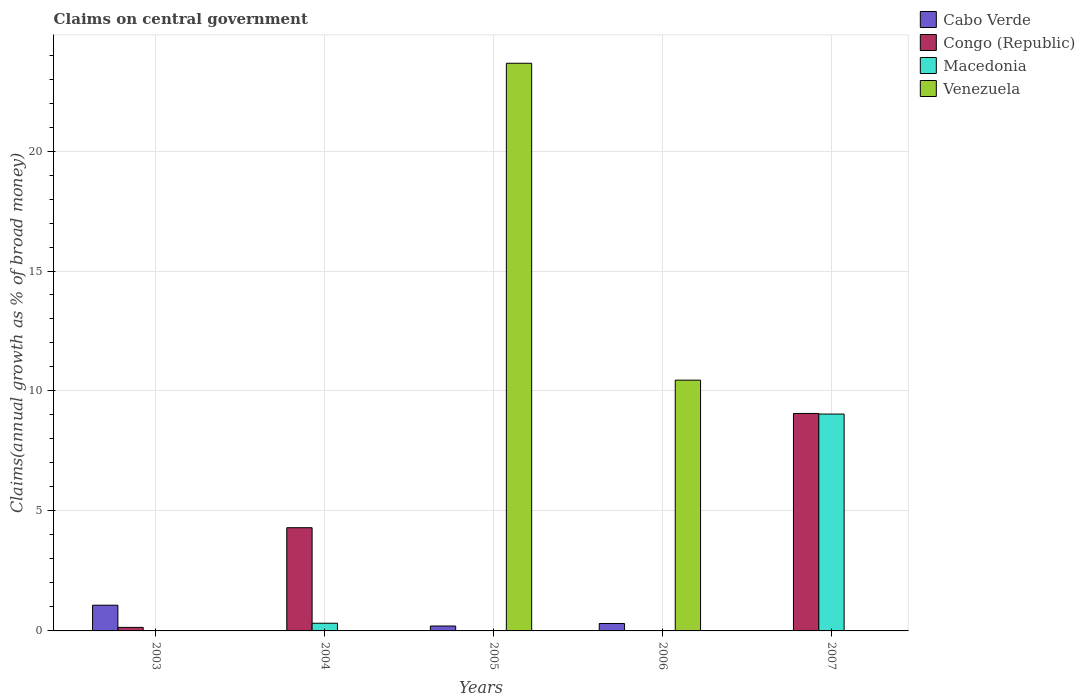How many different coloured bars are there?
Keep it short and to the point. 4. How many groups of bars are there?
Make the answer very short. 5. Are the number of bars on each tick of the X-axis equal?
Your answer should be compact. Yes. How many bars are there on the 5th tick from the left?
Provide a short and direct response. 2. How many bars are there on the 2nd tick from the right?
Give a very brief answer. 2. What is the label of the 5th group of bars from the left?
Offer a terse response. 2007. What is the percentage of broad money claimed on centeral government in Congo (Republic) in 2003?
Offer a very short reply. 0.15. Across all years, what is the maximum percentage of broad money claimed on centeral government in Venezuela?
Keep it short and to the point. 23.66. In which year was the percentage of broad money claimed on centeral government in Congo (Republic) maximum?
Your answer should be very brief. 2007. What is the total percentage of broad money claimed on centeral government in Venezuela in the graph?
Give a very brief answer. 34.11. What is the difference between the percentage of broad money claimed on centeral government in Congo (Republic) in 2004 and that in 2007?
Your answer should be compact. -4.76. What is the difference between the percentage of broad money claimed on centeral government in Venezuela in 2007 and the percentage of broad money claimed on centeral government in Cabo Verde in 2004?
Your answer should be very brief. 0. What is the average percentage of broad money claimed on centeral government in Venezuela per year?
Ensure brevity in your answer.  6.82. In the year 2004, what is the difference between the percentage of broad money claimed on centeral government in Congo (Republic) and percentage of broad money claimed on centeral government in Macedonia?
Give a very brief answer. 3.98. What is the ratio of the percentage of broad money claimed on centeral government in Congo (Republic) in 2004 to that in 2007?
Keep it short and to the point. 0.47. What is the difference between the highest and the second highest percentage of broad money claimed on centeral government in Cabo Verde?
Make the answer very short. 0.76. What is the difference between the highest and the lowest percentage of broad money claimed on centeral government in Congo (Republic)?
Keep it short and to the point. 9.06. In how many years, is the percentage of broad money claimed on centeral government in Venezuela greater than the average percentage of broad money claimed on centeral government in Venezuela taken over all years?
Make the answer very short. 2. Is it the case that in every year, the sum of the percentage of broad money claimed on centeral government in Cabo Verde and percentage of broad money claimed on centeral government in Macedonia is greater than the sum of percentage of broad money claimed on centeral government in Congo (Republic) and percentage of broad money claimed on centeral government in Venezuela?
Give a very brief answer. No. How many bars are there?
Give a very brief answer. 10. Are all the bars in the graph horizontal?
Your response must be concise. No. How many years are there in the graph?
Make the answer very short. 5. What is the difference between two consecutive major ticks on the Y-axis?
Ensure brevity in your answer.  5. Are the values on the major ticks of Y-axis written in scientific E-notation?
Keep it short and to the point. No. Does the graph contain grids?
Keep it short and to the point. Yes. Where does the legend appear in the graph?
Your answer should be compact. Top right. How are the legend labels stacked?
Your answer should be compact. Vertical. What is the title of the graph?
Your response must be concise. Claims on central government. Does "Lesotho" appear as one of the legend labels in the graph?
Provide a short and direct response. No. What is the label or title of the X-axis?
Provide a short and direct response. Years. What is the label or title of the Y-axis?
Give a very brief answer. Claims(annual growth as % of broad money). What is the Claims(annual growth as % of broad money) in Cabo Verde in 2003?
Offer a very short reply. 1.07. What is the Claims(annual growth as % of broad money) of Congo (Republic) in 2003?
Ensure brevity in your answer.  0.15. What is the Claims(annual growth as % of broad money) in Venezuela in 2003?
Make the answer very short. 0. What is the Claims(annual growth as % of broad money) of Cabo Verde in 2004?
Give a very brief answer. 0. What is the Claims(annual growth as % of broad money) in Congo (Republic) in 2004?
Provide a succinct answer. 4.3. What is the Claims(annual growth as % of broad money) in Macedonia in 2004?
Provide a succinct answer. 0.32. What is the Claims(annual growth as % of broad money) of Venezuela in 2004?
Offer a terse response. 0. What is the Claims(annual growth as % of broad money) in Cabo Verde in 2005?
Offer a very short reply. 0.21. What is the Claims(annual growth as % of broad money) of Congo (Republic) in 2005?
Keep it short and to the point. 0. What is the Claims(annual growth as % of broad money) of Macedonia in 2005?
Give a very brief answer. 0. What is the Claims(annual growth as % of broad money) in Venezuela in 2005?
Provide a succinct answer. 23.66. What is the Claims(annual growth as % of broad money) in Cabo Verde in 2006?
Ensure brevity in your answer.  0.31. What is the Claims(annual growth as % of broad money) of Congo (Republic) in 2006?
Keep it short and to the point. 0. What is the Claims(annual growth as % of broad money) in Venezuela in 2006?
Provide a succinct answer. 10.45. What is the Claims(annual growth as % of broad money) in Congo (Republic) in 2007?
Your answer should be compact. 9.06. What is the Claims(annual growth as % of broad money) in Macedonia in 2007?
Ensure brevity in your answer.  9.04. What is the Claims(annual growth as % of broad money) in Venezuela in 2007?
Ensure brevity in your answer.  0. Across all years, what is the maximum Claims(annual growth as % of broad money) of Cabo Verde?
Ensure brevity in your answer.  1.07. Across all years, what is the maximum Claims(annual growth as % of broad money) in Congo (Republic)?
Offer a very short reply. 9.06. Across all years, what is the maximum Claims(annual growth as % of broad money) of Macedonia?
Your answer should be very brief. 9.04. Across all years, what is the maximum Claims(annual growth as % of broad money) of Venezuela?
Provide a short and direct response. 23.66. Across all years, what is the minimum Claims(annual growth as % of broad money) of Cabo Verde?
Your answer should be compact. 0. Across all years, what is the minimum Claims(annual growth as % of broad money) of Congo (Republic)?
Make the answer very short. 0. Across all years, what is the minimum Claims(annual growth as % of broad money) of Macedonia?
Make the answer very short. 0. Across all years, what is the minimum Claims(annual growth as % of broad money) of Venezuela?
Provide a short and direct response. 0. What is the total Claims(annual growth as % of broad money) of Cabo Verde in the graph?
Your response must be concise. 1.59. What is the total Claims(annual growth as % of broad money) in Congo (Republic) in the graph?
Ensure brevity in your answer.  13.51. What is the total Claims(annual growth as % of broad money) in Macedonia in the graph?
Your response must be concise. 9.36. What is the total Claims(annual growth as % of broad money) in Venezuela in the graph?
Ensure brevity in your answer.  34.11. What is the difference between the Claims(annual growth as % of broad money) in Congo (Republic) in 2003 and that in 2004?
Your answer should be very brief. -4.15. What is the difference between the Claims(annual growth as % of broad money) in Cabo Verde in 2003 and that in 2005?
Your response must be concise. 0.87. What is the difference between the Claims(annual growth as % of broad money) of Cabo Verde in 2003 and that in 2006?
Ensure brevity in your answer.  0.76. What is the difference between the Claims(annual growth as % of broad money) of Congo (Republic) in 2003 and that in 2007?
Offer a very short reply. -8.92. What is the difference between the Claims(annual growth as % of broad money) of Congo (Republic) in 2004 and that in 2007?
Provide a short and direct response. -4.76. What is the difference between the Claims(annual growth as % of broad money) in Macedonia in 2004 and that in 2007?
Make the answer very short. -8.72. What is the difference between the Claims(annual growth as % of broad money) in Cabo Verde in 2005 and that in 2006?
Give a very brief answer. -0.1. What is the difference between the Claims(annual growth as % of broad money) in Venezuela in 2005 and that in 2006?
Make the answer very short. 13.21. What is the difference between the Claims(annual growth as % of broad money) in Cabo Verde in 2003 and the Claims(annual growth as % of broad money) in Congo (Republic) in 2004?
Make the answer very short. -3.23. What is the difference between the Claims(annual growth as % of broad money) in Cabo Verde in 2003 and the Claims(annual growth as % of broad money) in Macedonia in 2004?
Your answer should be compact. 0.75. What is the difference between the Claims(annual growth as % of broad money) of Congo (Republic) in 2003 and the Claims(annual growth as % of broad money) of Macedonia in 2004?
Offer a very short reply. -0.17. What is the difference between the Claims(annual growth as % of broad money) of Cabo Verde in 2003 and the Claims(annual growth as % of broad money) of Venezuela in 2005?
Your answer should be very brief. -22.59. What is the difference between the Claims(annual growth as % of broad money) of Congo (Republic) in 2003 and the Claims(annual growth as % of broad money) of Venezuela in 2005?
Your answer should be compact. -23.51. What is the difference between the Claims(annual growth as % of broad money) of Cabo Verde in 2003 and the Claims(annual growth as % of broad money) of Venezuela in 2006?
Offer a very short reply. -9.38. What is the difference between the Claims(annual growth as % of broad money) in Congo (Republic) in 2003 and the Claims(annual growth as % of broad money) in Venezuela in 2006?
Offer a very short reply. -10.3. What is the difference between the Claims(annual growth as % of broad money) in Cabo Verde in 2003 and the Claims(annual growth as % of broad money) in Congo (Republic) in 2007?
Your answer should be very brief. -7.99. What is the difference between the Claims(annual growth as % of broad money) in Cabo Verde in 2003 and the Claims(annual growth as % of broad money) in Macedonia in 2007?
Provide a succinct answer. -7.97. What is the difference between the Claims(annual growth as % of broad money) of Congo (Republic) in 2003 and the Claims(annual growth as % of broad money) of Macedonia in 2007?
Your response must be concise. -8.89. What is the difference between the Claims(annual growth as % of broad money) of Congo (Republic) in 2004 and the Claims(annual growth as % of broad money) of Venezuela in 2005?
Ensure brevity in your answer.  -19.36. What is the difference between the Claims(annual growth as % of broad money) in Macedonia in 2004 and the Claims(annual growth as % of broad money) in Venezuela in 2005?
Your answer should be very brief. -23.34. What is the difference between the Claims(annual growth as % of broad money) of Congo (Republic) in 2004 and the Claims(annual growth as % of broad money) of Venezuela in 2006?
Your answer should be very brief. -6.15. What is the difference between the Claims(annual growth as % of broad money) of Macedonia in 2004 and the Claims(annual growth as % of broad money) of Venezuela in 2006?
Ensure brevity in your answer.  -10.13. What is the difference between the Claims(annual growth as % of broad money) in Congo (Republic) in 2004 and the Claims(annual growth as % of broad money) in Macedonia in 2007?
Offer a very short reply. -4.74. What is the difference between the Claims(annual growth as % of broad money) of Cabo Verde in 2005 and the Claims(annual growth as % of broad money) of Venezuela in 2006?
Make the answer very short. -10.25. What is the difference between the Claims(annual growth as % of broad money) in Cabo Verde in 2005 and the Claims(annual growth as % of broad money) in Congo (Republic) in 2007?
Give a very brief answer. -8.86. What is the difference between the Claims(annual growth as % of broad money) in Cabo Verde in 2005 and the Claims(annual growth as % of broad money) in Macedonia in 2007?
Your answer should be very brief. -8.83. What is the difference between the Claims(annual growth as % of broad money) of Cabo Verde in 2006 and the Claims(annual growth as % of broad money) of Congo (Republic) in 2007?
Your response must be concise. -8.75. What is the difference between the Claims(annual growth as % of broad money) in Cabo Verde in 2006 and the Claims(annual growth as % of broad money) in Macedonia in 2007?
Ensure brevity in your answer.  -8.73. What is the average Claims(annual growth as % of broad money) in Cabo Verde per year?
Keep it short and to the point. 0.32. What is the average Claims(annual growth as % of broad money) of Congo (Republic) per year?
Your answer should be very brief. 2.7. What is the average Claims(annual growth as % of broad money) in Macedonia per year?
Give a very brief answer. 1.87. What is the average Claims(annual growth as % of broad money) in Venezuela per year?
Give a very brief answer. 6.82. In the year 2003, what is the difference between the Claims(annual growth as % of broad money) in Cabo Verde and Claims(annual growth as % of broad money) in Congo (Republic)?
Provide a succinct answer. 0.92. In the year 2004, what is the difference between the Claims(annual growth as % of broad money) of Congo (Republic) and Claims(annual growth as % of broad money) of Macedonia?
Keep it short and to the point. 3.98. In the year 2005, what is the difference between the Claims(annual growth as % of broad money) in Cabo Verde and Claims(annual growth as % of broad money) in Venezuela?
Give a very brief answer. -23.45. In the year 2006, what is the difference between the Claims(annual growth as % of broad money) of Cabo Verde and Claims(annual growth as % of broad money) of Venezuela?
Ensure brevity in your answer.  -10.14. In the year 2007, what is the difference between the Claims(annual growth as % of broad money) of Congo (Republic) and Claims(annual growth as % of broad money) of Macedonia?
Your answer should be compact. 0.02. What is the ratio of the Claims(annual growth as % of broad money) of Congo (Republic) in 2003 to that in 2004?
Provide a short and direct response. 0.03. What is the ratio of the Claims(annual growth as % of broad money) of Cabo Verde in 2003 to that in 2005?
Provide a short and direct response. 5.22. What is the ratio of the Claims(annual growth as % of broad money) in Cabo Verde in 2003 to that in 2006?
Keep it short and to the point. 3.46. What is the ratio of the Claims(annual growth as % of broad money) in Congo (Republic) in 2003 to that in 2007?
Offer a very short reply. 0.02. What is the ratio of the Claims(annual growth as % of broad money) in Congo (Republic) in 2004 to that in 2007?
Keep it short and to the point. 0.47. What is the ratio of the Claims(annual growth as % of broad money) in Macedonia in 2004 to that in 2007?
Your answer should be compact. 0.04. What is the ratio of the Claims(annual growth as % of broad money) of Cabo Verde in 2005 to that in 2006?
Keep it short and to the point. 0.66. What is the ratio of the Claims(annual growth as % of broad money) of Venezuela in 2005 to that in 2006?
Your response must be concise. 2.26. What is the difference between the highest and the second highest Claims(annual growth as % of broad money) of Cabo Verde?
Keep it short and to the point. 0.76. What is the difference between the highest and the second highest Claims(annual growth as % of broad money) of Congo (Republic)?
Your response must be concise. 4.76. What is the difference between the highest and the lowest Claims(annual growth as % of broad money) of Cabo Verde?
Your response must be concise. 1.07. What is the difference between the highest and the lowest Claims(annual growth as % of broad money) in Congo (Republic)?
Provide a short and direct response. 9.06. What is the difference between the highest and the lowest Claims(annual growth as % of broad money) in Macedonia?
Give a very brief answer. 9.04. What is the difference between the highest and the lowest Claims(annual growth as % of broad money) in Venezuela?
Provide a succinct answer. 23.66. 